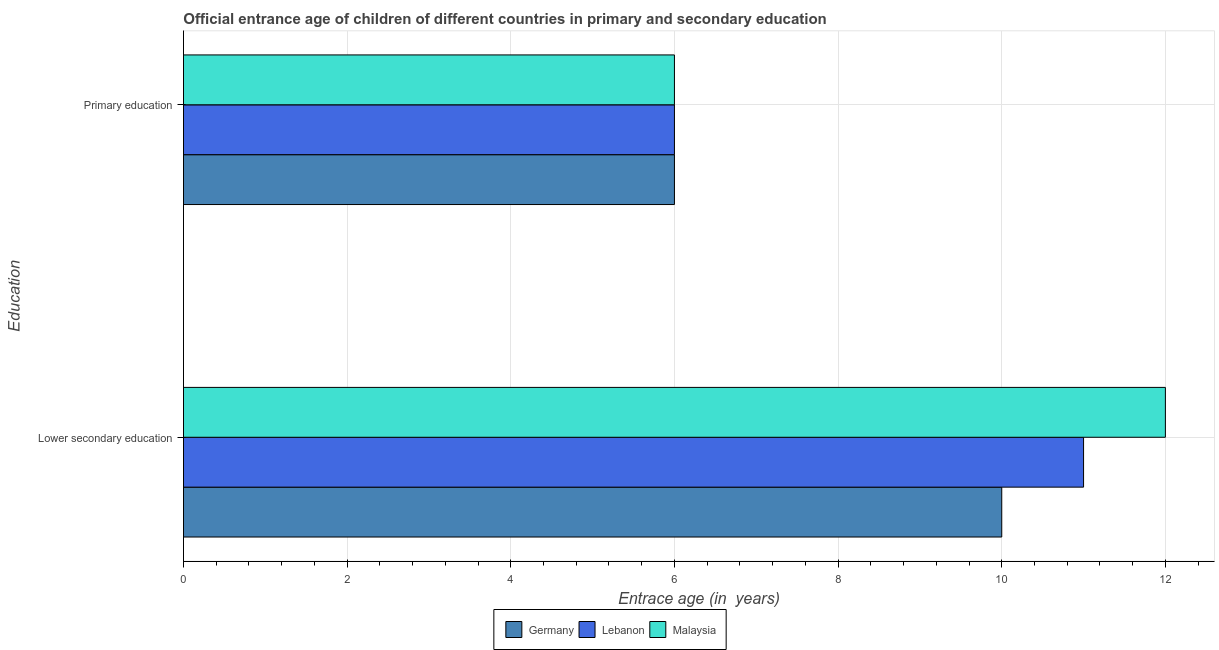Are the number of bars per tick equal to the number of legend labels?
Provide a succinct answer. Yes. Are the number of bars on each tick of the Y-axis equal?
Ensure brevity in your answer.  Yes. How many bars are there on the 2nd tick from the top?
Offer a very short reply. 3. How many bars are there on the 1st tick from the bottom?
Offer a terse response. 3. What is the label of the 2nd group of bars from the top?
Ensure brevity in your answer.  Lower secondary education. What is the entrance age of chiildren in primary education in Malaysia?
Offer a very short reply. 6. Across all countries, what is the maximum entrance age of children in lower secondary education?
Give a very brief answer. 12. Across all countries, what is the minimum entrance age of chiildren in primary education?
Give a very brief answer. 6. In which country was the entrance age of children in lower secondary education maximum?
Offer a terse response. Malaysia. What is the total entrance age of children in lower secondary education in the graph?
Offer a terse response. 33. What is the difference between the entrance age of chiildren in primary education in Lebanon and that in Germany?
Keep it short and to the point. 0. What is the difference between the entrance age of children in lower secondary education in Germany and the entrance age of chiildren in primary education in Malaysia?
Keep it short and to the point. 4. What is the difference between the entrance age of chiildren in primary education and entrance age of children in lower secondary education in Germany?
Your answer should be very brief. -4. Is the entrance age of chiildren in primary education in Germany less than that in Malaysia?
Provide a short and direct response. No. In how many countries, is the entrance age of children in lower secondary education greater than the average entrance age of children in lower secondary education taken over all countries?
Your answer should be compact. 1. What does the 3rd bar from the top in Lower secondary education represents?
Provide a succinct answer. Germany. What does the 2nd bar from the bottom in Lower secondary education represents?
Make the answer very short. Lebanon. Are the values on the major ticks of X-axis written in scientific E-notation?
Give a very brief answer. No. How are the legend labels stacked?
Ensure brevity in your answer.  Horizontal. What is the title of the graph?
Make the answer very short. Official entrance age of children of different countries in primary and secondary education. Does "Indonesia" appear as one of the legend labels in the graph?
Your answer should be compact. No. What is the label or title of the X-axis?
Your response must be concise. Entrace age (in  years). What is the label or title of the Y-axis?
Provide a succinct answer. Education. What is the Entrace age (in  years) in Germany in Lower secondary education?
Offer a very short reply. 10. Across all Education, what is the maximum Entrace age (in  years) of Germany?
Give a very brief answer. 10. Across all Education, what is the maximum Entrace age (in  years) of Lebanon?
Your answer should be very brief. 11. Across all Education, what is the maximum Entrace age (in  years) in Malaysia?
Ensure brevity in your answer.  12. Across all Education, what is the minimum Entrace age (in  years) in Germany?
Make the answer very short. 6. Across all Education, what is the minimum Entrace age (in  years) of Lebanon?
Your answer should be very brief. 6. Across all Education, what is the minimum Entrace age (in  years) of Malaysia?
Give a very brief answer. 6. What is the total Entrace age (in  years) of Germany in the graph?
Offer a terse response. 16. What is the total Entrace age (in  years) in Lebanon in the graph?
Your answer should be compact. 17. What is the difference between the Entrace age (in  years) of Germany in Lower secondary education and that in Primary education?
Your answer should be compact. 4. What is the difference between the Entrace age (in  years) of Lebanon in Lower secondary education and that in Primary education?
Give a very brief answer. 5. What is the difference between the Entrace age (in  years) in Malaysia in Lower secondary education and that in Primary education?
Your answer should be compact. 6. What is the difference between the Entrace age (in  years) in Germany in Lower secondary education and the Entrace age (in  years) in Lebanon in Primary education?
Make the answer very short. 4. What is the average Entrace age (in  years) in Lebanon per Education?
Offer a terse response. 8.5. What is the difference between the Entrace age (in  years) in Germany and Entrace age (in  years) in Malaysia in Lower secondary education?
Keep it short and to the point. -2. What is the ratio of the Entrace age (in  years) in Germany in Lower secondary education to that in Primary education?
Make the answer very short. 1.67. What is the ratio of the Entrace age (in  years) in Lebanon in Lower secondary education to that in Primary education?
Your answer should be very brief. 1.83. What is the ratio of the Entrace age (in  years) in Malaysia in Lower secondary education to that in Primary education?
Offer a very short reply. 2. What is the difference between the highest and the second highest Entrace age (in  years) in Germany?
Your answer should be compact. 4. What is the difference between the highest and the lowest Entrace age (in  years) of Malaysia?
Your response must be concise. 6. 